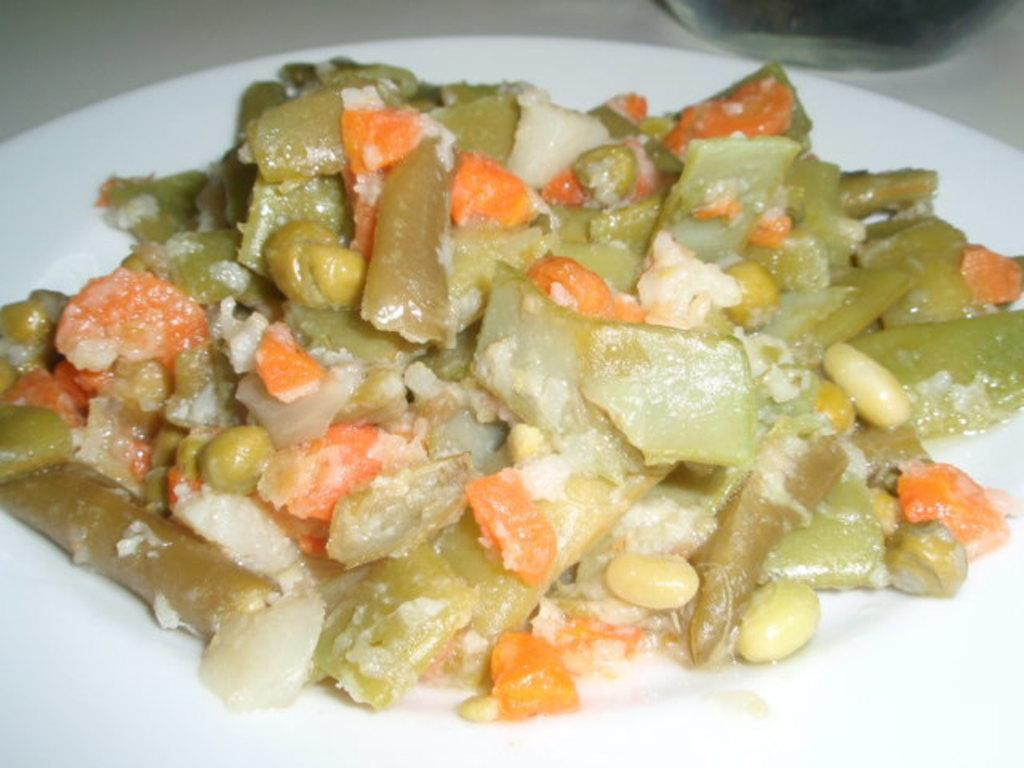What is present on the plate in the image? There are food items in a plate in the image. Can you describe the object on the platform in the image? Unfortunately, the facts provided do not give enough information to describe the object on the platform. How many times does the lettuce appear in the image? There is no lettuce present in the image. 